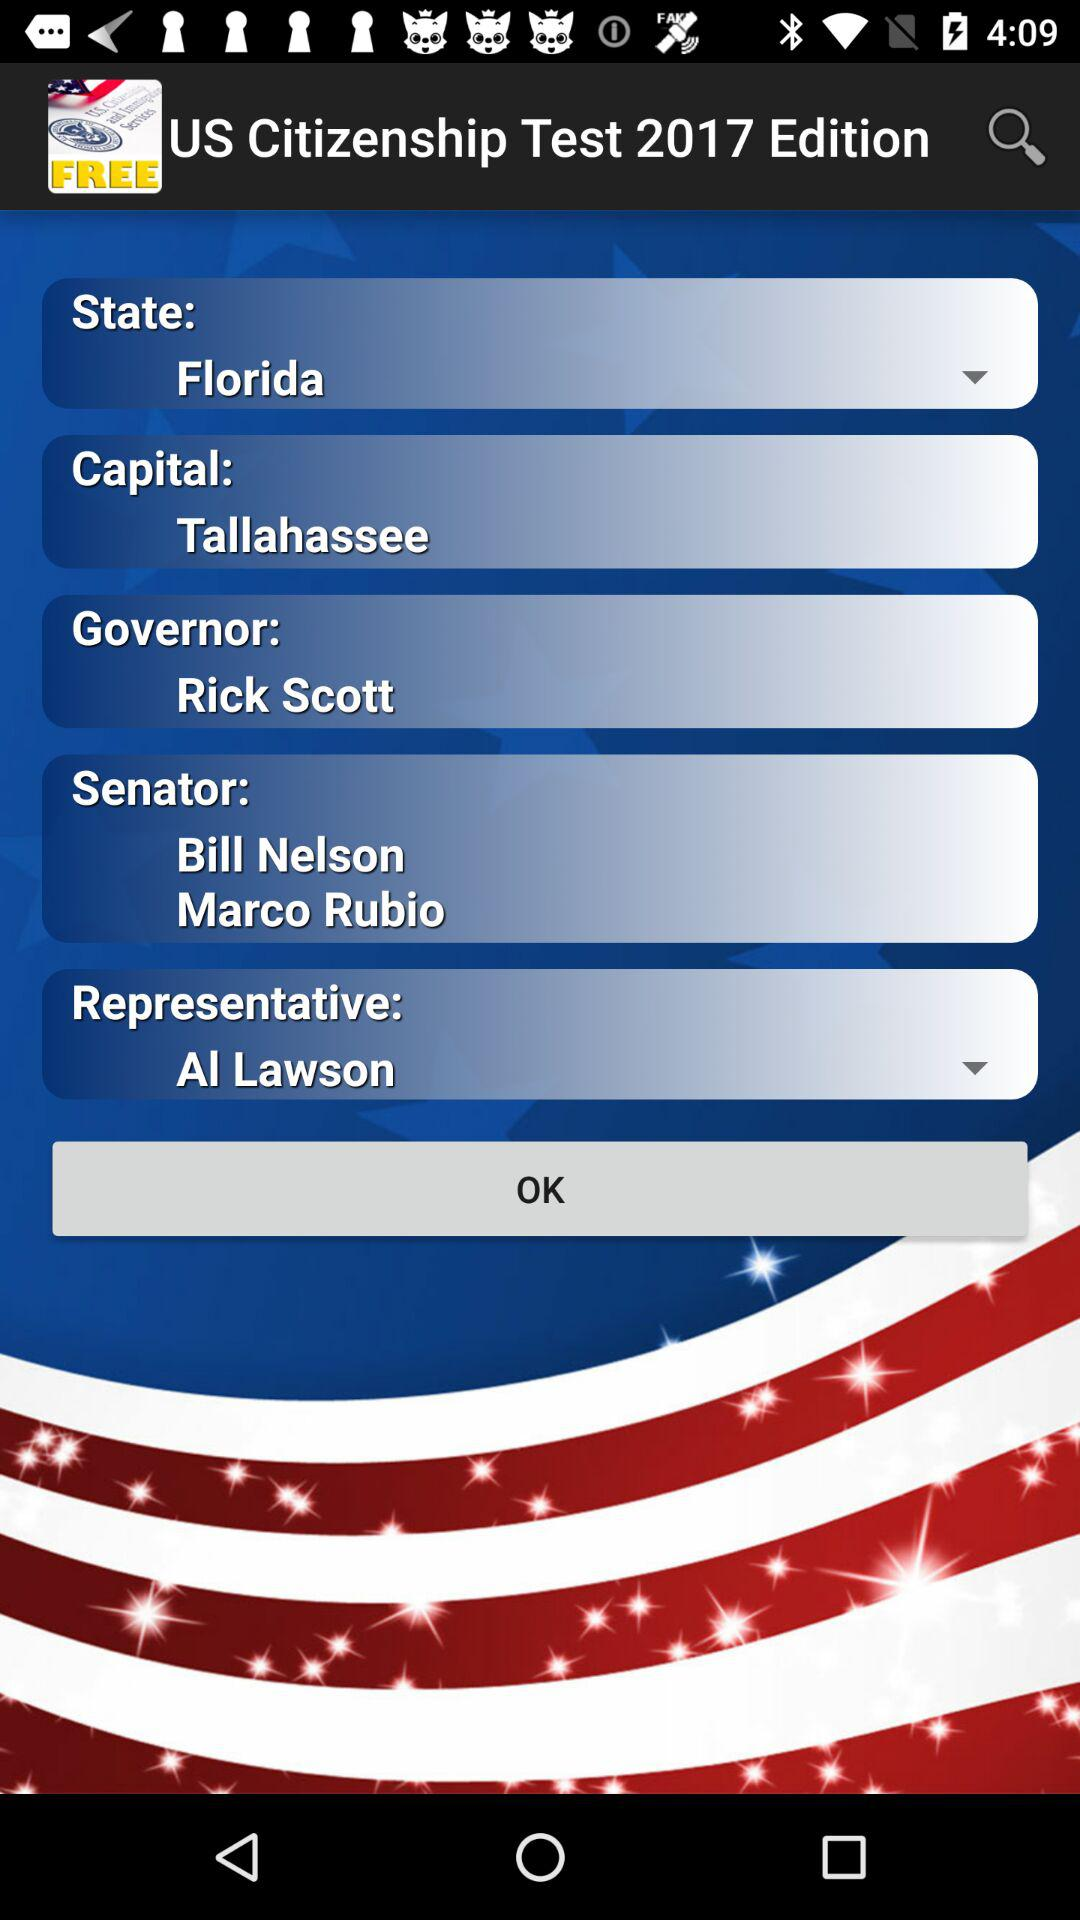What is the capital? The capital is Tallahassee. 